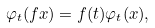Convert formula to latex. <formula><loc_0><loc_0><loc_500><loc_500>\varphi _ { t } ( f x ) = f ( t ) \varphi _ { t } ( x ) ,</formula> 